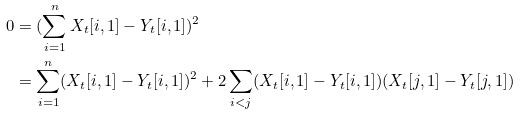Convert formula to latex. <formula><loc_0><loc_0><loc_500><loc_500>0 & = ( \sum _ { i = 1 } ^ { n } X _ { t } [ i , 1 ] - Y _ { t } [ i , 1 ] ) ^ { 2 } \\ & = \sum _ { i = 1 } ^ { n } ( X _ { t } [ i , 1 ] - Y _ { t } [ i , 1 ] ) ^ { 2 } + 2 \sum _ { i < j } ( X _ { t } [ i , 1 ] - Y _ { t } [ i , 1 ] ) ( X _ { t } [ j , 1 ] - Y _ { t } [ j , 1 ] )</formula> 